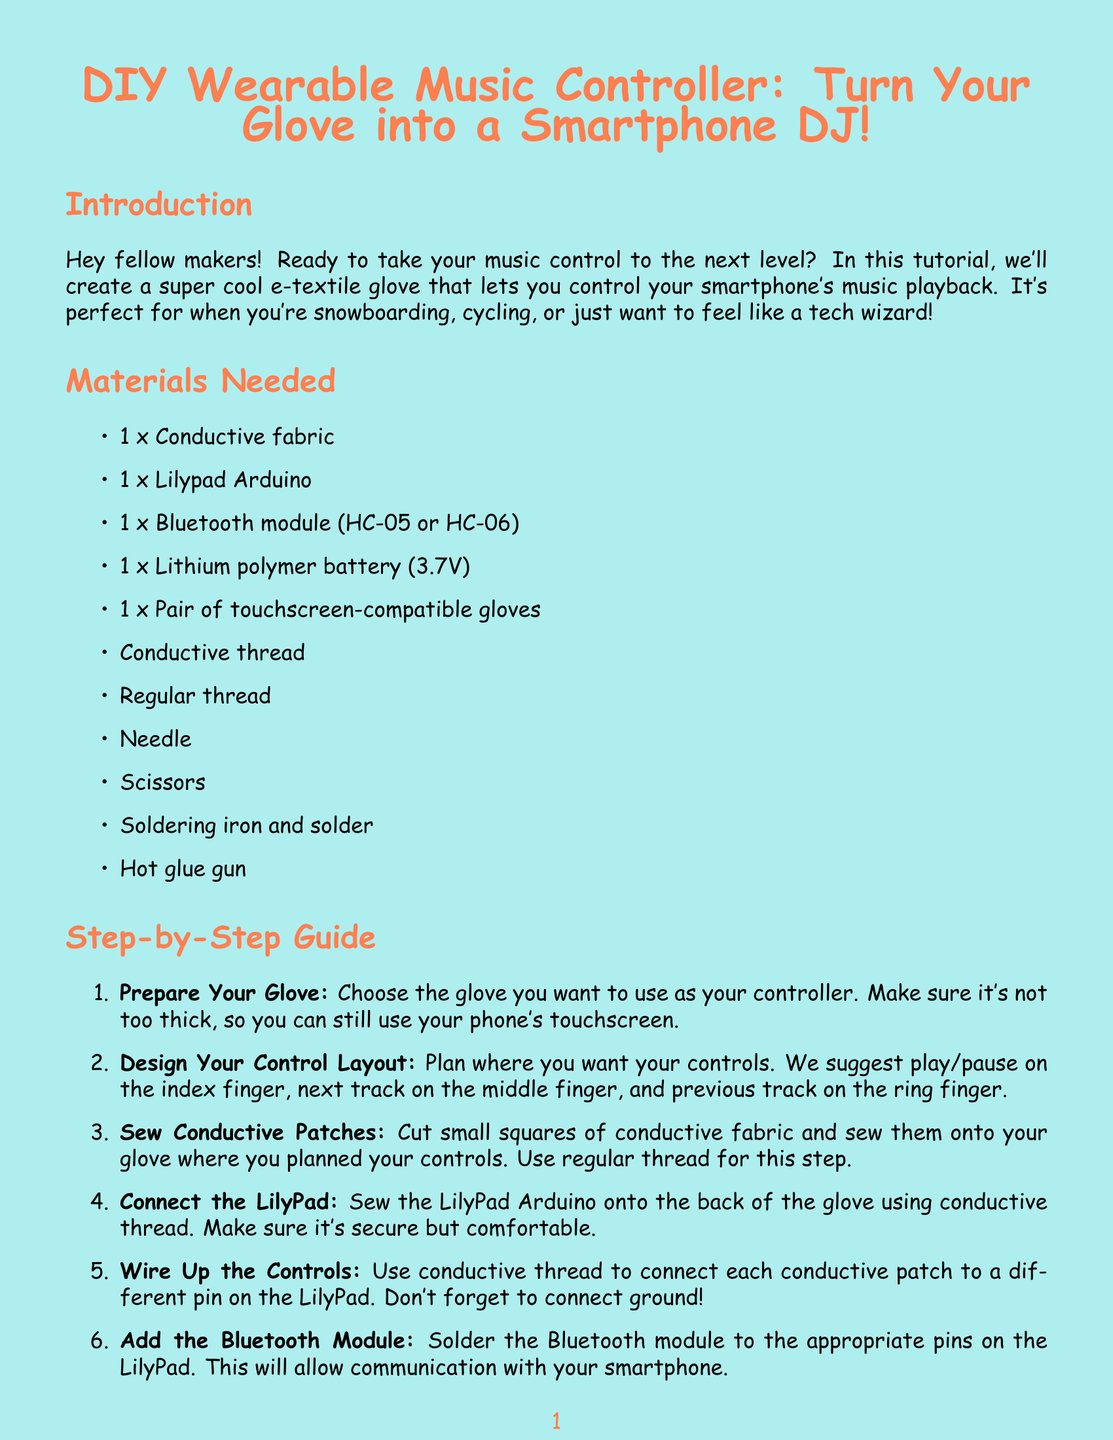What is the title of the newsletter? The title is mentioned at the beginning of the document as "DIY Wearable Music Controller: Turn Your Glove into a Smartphone DJ!"
Answer: DIY Wearable Music Controller: Turn Your Glove into a Smartphone DJ! How many materials are needed? The document lists the materials required for the project, totaling eleven items.
Answer: 11 What is suggested for the control layout on the glove? The document suggests play/pause on the index finger, next track on the middle finger, and previous track on the ring finger.
Answer: Play/pause, next track, previous track What should you use to sew the LilyPad onto the glove? The guide specifies using conductive thread to sew the LilyPad Arduino onto the glove.
Answer: Conductive thread If Bluetooth won't connect, what can you check? The troubleshooting section advises checking if the Bluetooth module is correctly soldered and if the phone's Bluetooth is turned on.
Answer: Bluetooth module soldering What is one of the tips for using the glove in sports? The tips and tricks section mentions considering adding a waterproof layer over the electronics for sports use.
Answer: Waterproof layer How should you secure the lithium polymer battery? The guide suggests using hot glue to secure the battery in a comfortable spot on the glove.
Answer: Hot glue What type of app should you download for your smartphone? The guide recommends downloading a Bluetooth MIDI app like 'MIDI BLE Connect' for Android or 'MidiWrist' for iOS.
Answer: Bluetooth MIDI app Who is the author of the newsletter? The document concludes with a brief description of the author, identifying them as Alex.
Answer: Alex 